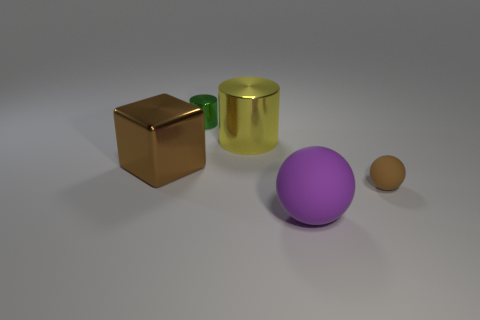What is the material of the small brown sphere?
Give a very brief answer. Rubber. What material is the brown object that is the same size as the green cylinder?
Your answer should be very brief. Rubber. Is there a metal cylinder of the same size as the purple object?
Keep it short and to the point. Yes. Is the number of metal cylinders that are in front of the large metallic cylinder the same as the number of green cylinders that are to the left of the block?
Your response must be concise. Yes. Is the number of small metallic cylinders greater than the number of large green rubber spheres?
Keep it short and to the point. Yes. What number of rubber objects are big purple cylinders or blocks?
Offer a very short reply. 0. How many small matte objects are the same color as the big metallic cylinder?
Your answer should be compact. 0. There is a brown thing left of the tiny thing in front of the tiny object that is behind the large yellow shiny thing; what is its material?
Provide a short and direct response. Metal. The sphere that is on the right side of the matte thing that is on the left side of the tiny brown matte object is what color?
Your response must be concise. Brown. What number of large things are either green shiny things or red matte things?
Provide a succinct answer. 0. 